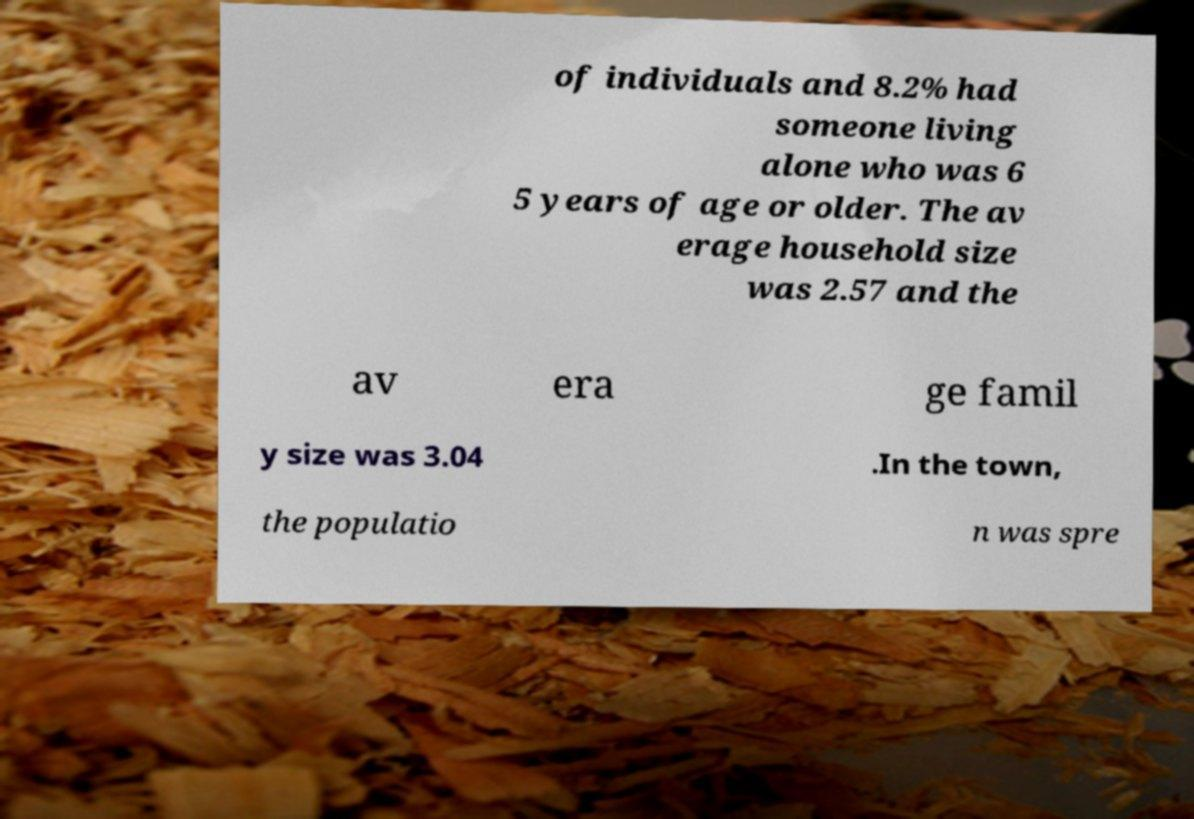Could you assist in decoding the text presented in this image and type it out clearly? of individuals and 8.2% had someone living alone who was 6 5 years of age or older. The av erage household size was 2.57 and the av era ge famil y size was 3.04 .In the town, the populatio n was spre 